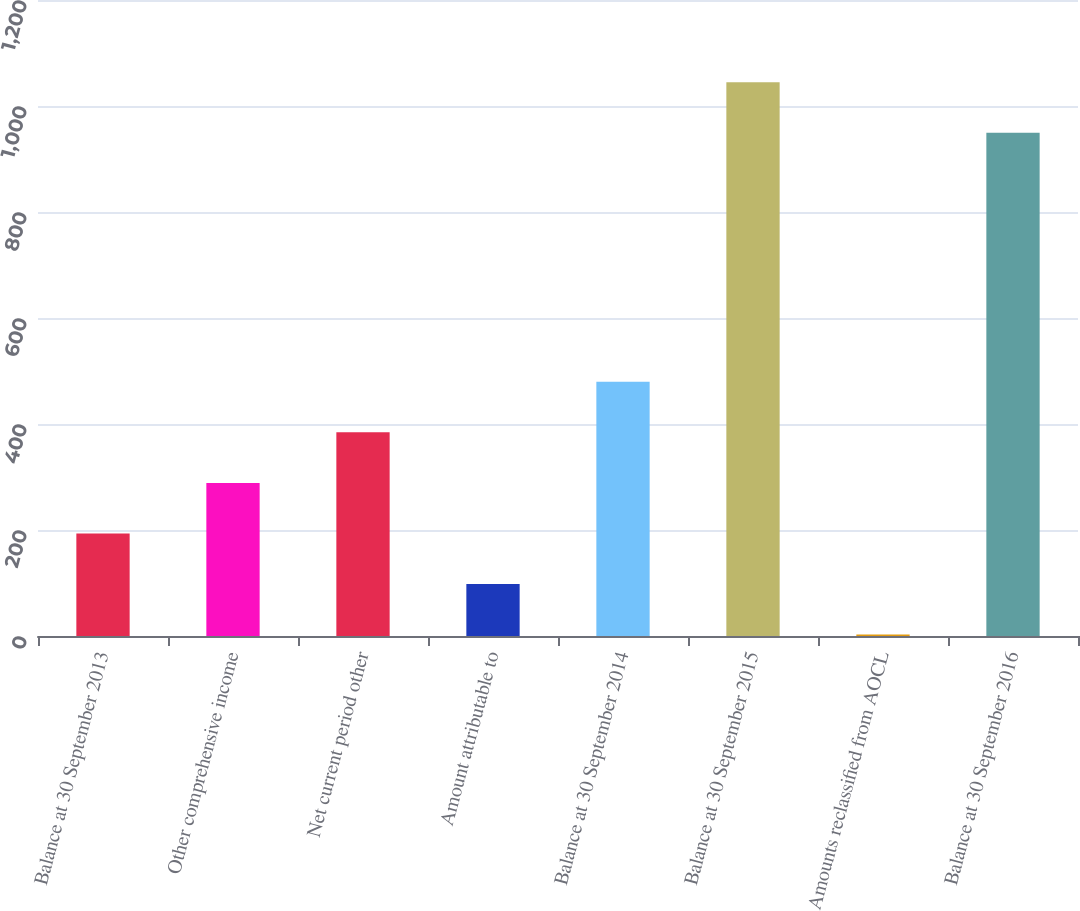Convert chart. <chart><loc_0><loc_0><loc_500><loc_500><bar_chart><fcel>Balance at 30 September 2013<fcel>Other comprehensive income<fcel>Net current period other<fcel>Amount attributable to<fcel>Balance at 30 September 2014<fcel>Balance at 30 September 2015<fcel>Amounts reclassified from AOCL<fcel>Balance at 30 September 2016<nl><fcel>193.46<fcel>288.84<fcel>384.22<fcel>98.08<fcel>479.6<fcel>1044.68<fcel>2.7<fcel>949.3<nl></chart> 